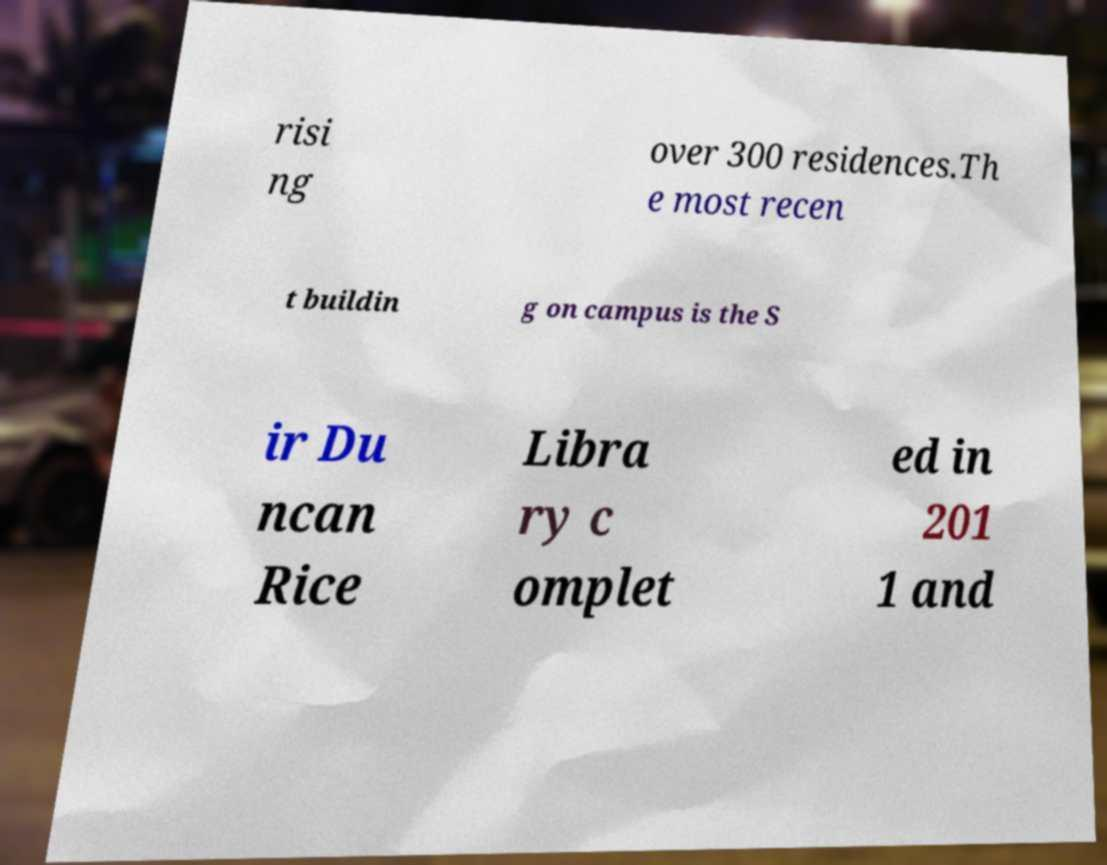Please identify and transcribe the text found in this image. risi ng over 300 residences.Th e most recen t buildin g on campus is the S ir Du ncan Rice Libra ry c omplet ed in 201 1 and 